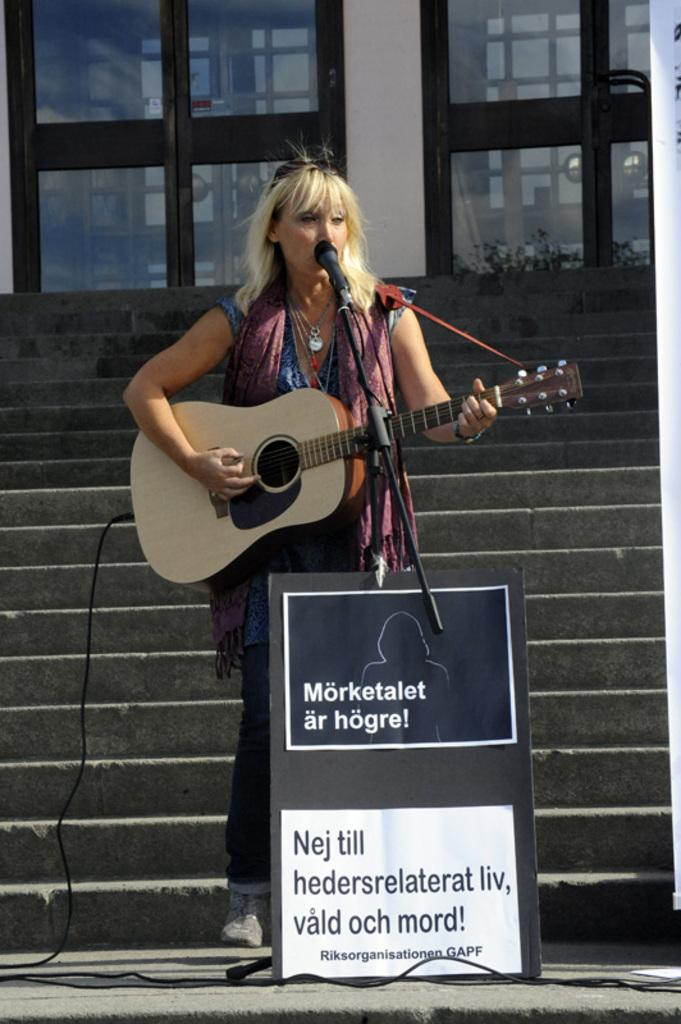What is the woman in the image doing? The woman is singing on a mic and playing a guitar. What is the woman's hair color? The woman has blond hair. What can be seen in the background of the image? There is a building visible in the background of the image. Where is the dog located in the image? There is no dog present in the image. What type of rifle is the woman holding while singing on the mic? There is no rifle present in the image; the woman is holding a guitar. 